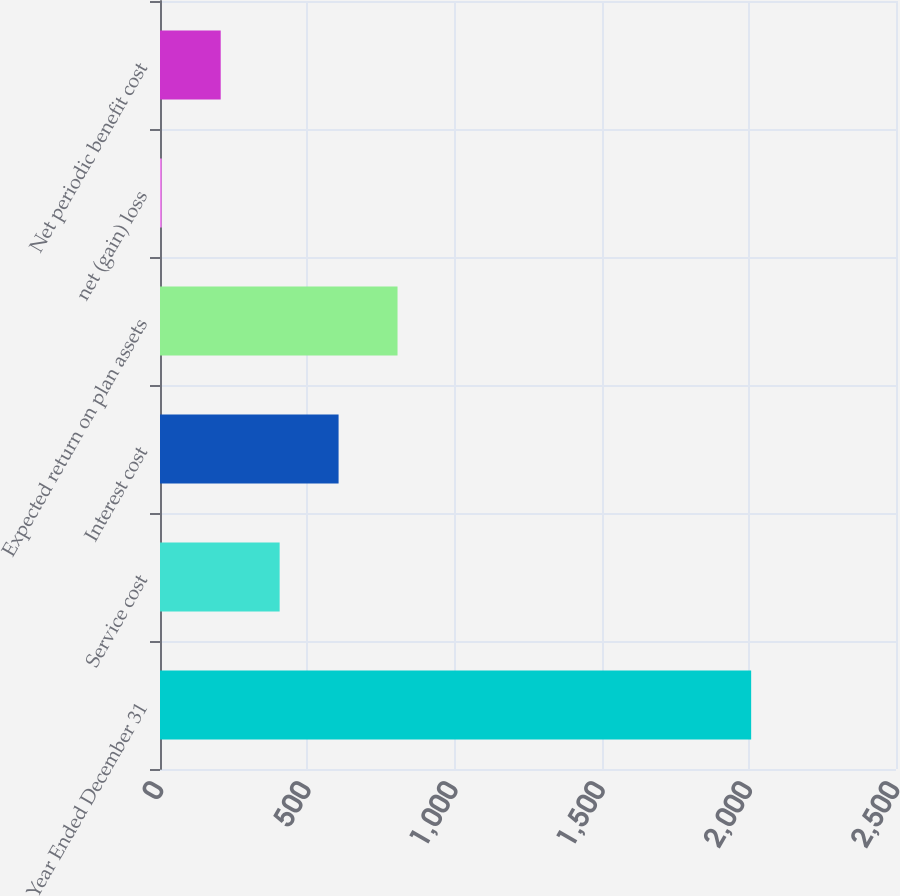<chart> <loc_0><loc_0><loc_500><loc_500><bar_chart><fcel>Year Ended December 31<fcel>Service cost<fcel>Interest cost<fcel>Expected return on plan assets<fcel>net (gain) loss<fcel>Net periodic benefit cost<nl><fcel>2008<fcel>406.4<fcel>606.6<fcel>806.8<fcel>6<fcel>206.2<nl></chart> 